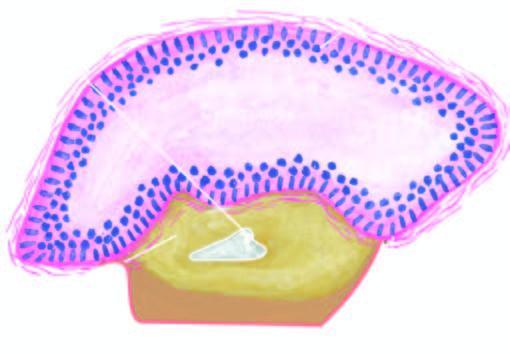what are conspicuously absent?
Answer the question using a single word or phrase. Inflammatory changes 